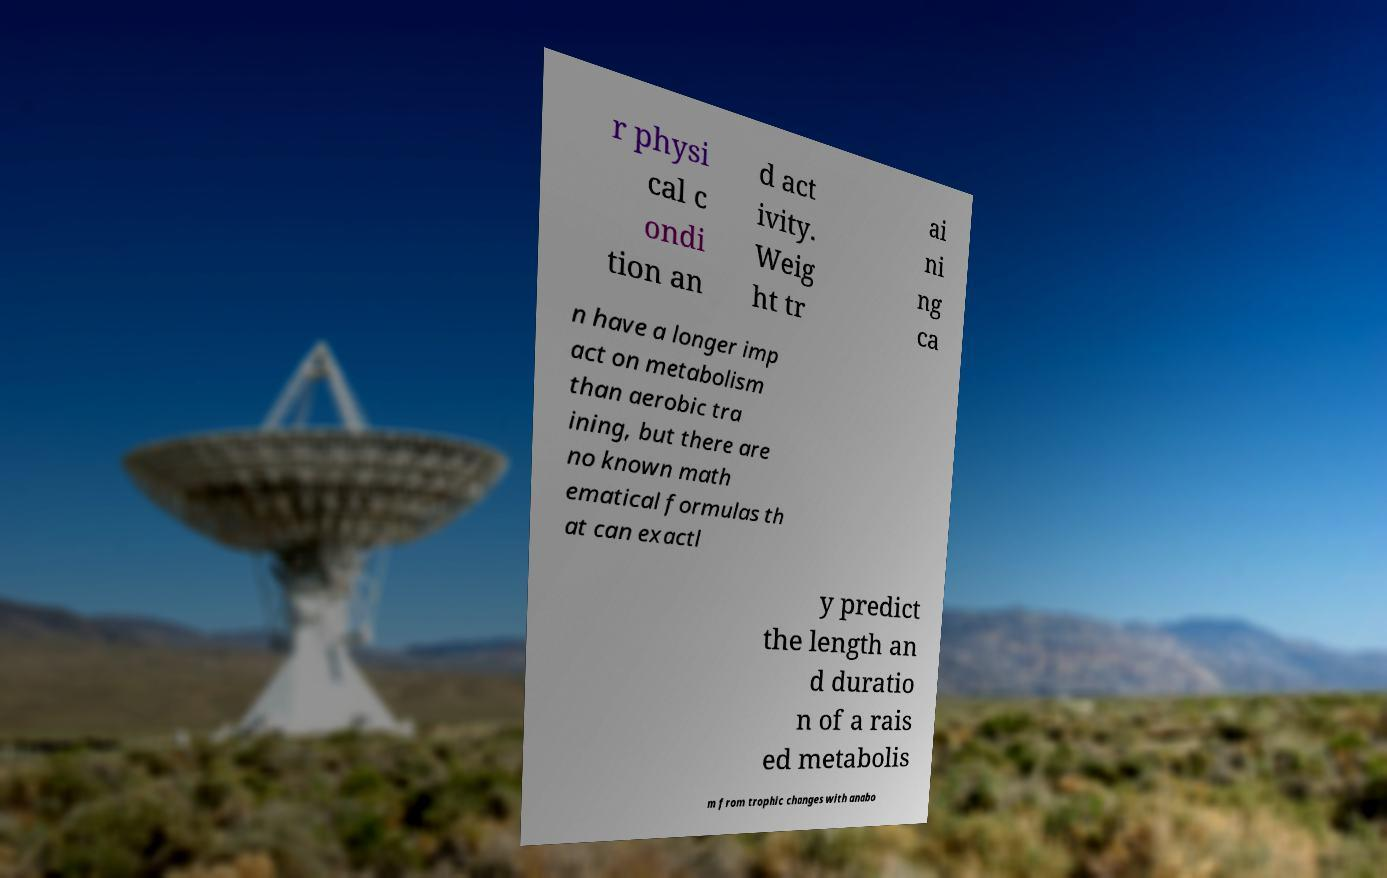Please read and relay the text visible in this image. What does it say? r physi cal c ondi tion an d act ivity. Weig ht tr ai ni ng ca n have a longer imp act on metabolism than aerobic tra ining, but there are no known math ematical formulas th at can exactl y predict the length an d duratio n of a rais ed metabolis m from trophic changes with anabo 